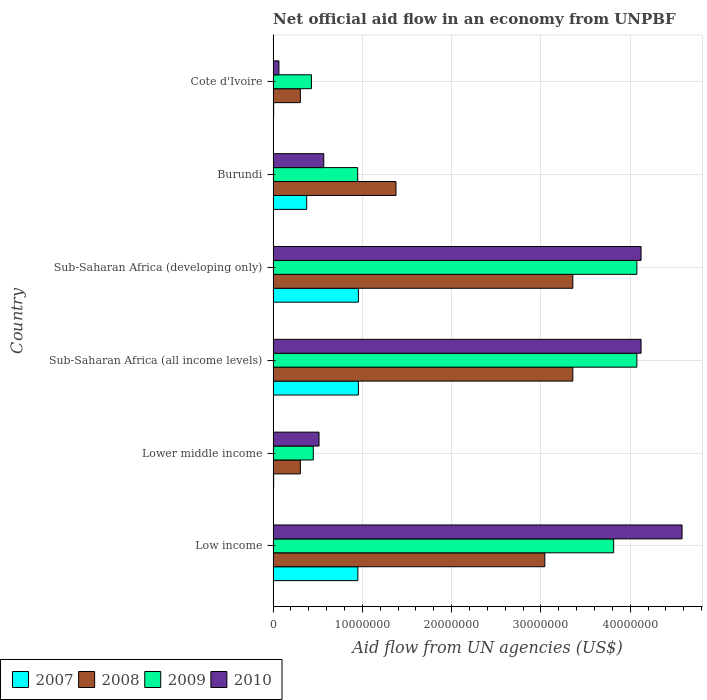How many groups of bars are there?
Keep it short and to the point. 6. Are the number of bars per tick equal to the number of legend labels?
Provide a short and direct response. Yes. Are the number of bars on each tick of the Y-axis equal?
Your answer should be compact. Yes. How many bars are there on the 1st tick from the top?
Your response must be concise. 4. What is the label of the 2nd group of bars from the top?
Your answer should be very brief. Burundi. What is the net official aid flow in 2008 in Sub-Saharan Africa (developing only)?
Give a very brief answer. 3.36e+07. Across all countries, what is the maximum net official aid flow in 2010?
Offer a very short reply. 4.58e+07. Across all countries, what is the minimum net official aid flow in 2008?
Offer a terse response. 3.05e+06. In which country was the net official aid flow in 2009 maximum?
Your answer should be very brief. Sub-Saharan Africa (all income levels). In which country was the net official aid flow in 2007 minimum?
Offer a very short reply. Lower middle income. What is the total net official aid flow in 2010 in the graph?
Offer a terse response. 1.40e+08. What is the difference between the net official aid flow in 2009 in Low income and that in Lower middle income?
Provide a succinct answer. 3.36e+07. What is the difference between the net official aid flow in 2009 in Lower middle income and the net official aid flow in 2007 in Cote d'Ivoire?
Offer a very short reply. 4.44e+06. What is the average net official aid flow in 2008 per country?
Provide a short and direct response. 1.96e+07. What is the difference between the net official aid flow in 2007 and net official aid flow in 2010 in Cote d'Ivoire?
Your answer should be compact. -5.90e+05. In how many countries, is the net official aid flow in 2010 greater than 42000000 US$?
Offer a very short reply. 1. Is the difference between the net official aid flow in 2007 in Burundi and Low income greater than the difference between the net official aid flow in 2010 in Burundi and Low income?
Provide a succinct answer. Yes. What is the difference between the highest and the second highest net official aid flow in 2008?
Your answer should be compact. 0. What is the difference between the highest and the lowest net official aid flow in 2007?
Provide a short and direct response. 9.49e+06. In how many countries, is the net official aid flow in 2008 greater than the average net official aid flow in 2008 taken over all countries?
Provide a succinct answer. 3. What does the 1st bar from the top in Sub-Saharan Africa (developing only) represents?
Offer a terse response. 2010. Is it the case that in every country, the sum of the net official aid flow in 2009 and net official aid flow in 2007 is greater than the net official aid flow in 2010?
Your answer should be compact. No. How many countries are there in the graph?
Offer a very short reply. 6. Are the values on the major ticks of X-axis written in scientific E-notation?
Provide a short and direct response. No. Does the graph contain grids?
Offer a very short reply. Yes. How many legend labels are there?
Offer a terse response. 4. What is the title of the graph?
Your answer should be compact. Net official aid flow in an economy from UNPBF. Does "2009" appear as one of the legend labels in the graph?
Ensure brevity in your answer.  Yes. What is the label or title of the X-axis?
Ensure brevity in your answer.  Aid flow from UN agencies (US$). What is the Aid flow from UN agencies (US$) in 2007 in Low income?
Make the answer very short. 9.49e+06. What is the Aid flow from UN agencies (US$) in 2008 in Low income?
Your answer should be very brief. 3.04e+07. What is the Aid flow from UN agencies (US$) in 2009 in Low income?
Offer a terse response. 3.81e+07. What is the Aid flow from UN agencies (US$) of 2010 in Low income?
Offer a very short reply. 4.58e+07. What is the Aid flow from UN agencies (US$) of 2008 in Lower middle income?
Make the answer very short. 3.05e+06. What is the Aid flow from UN agencies (US$) in 2009 in Lower middle income?
Your answer should be very brief. 4.50e+06. What is the Aid flow from UN agencies (US$) of 2010 in Lower middle income?
Give a very brief answer. 5.14e+06. What is the Aid flow from UN agencies (US$) in 2007 in Sub-Saharan Africa (all income levels)?
Make the answer very short. 9.55e+06. What is the Aid flow from UN agencies (US$) in 2008 in Sub-Saharan Africa (all income levels)?
Provide a short and direct response. 3.36e+07. What is the Aid flow from UN agencies (US$) of 2009 in Sub-Saharan Africa (all income levels)?
Offer a very short reply. 4.07e+07. What is the Aid flow from UN agencies (US$) in 2010 in Sub-Saharan Africa (all income levels)?
Your answer should be very brief. 4.12e+07. What is the Aid flow from UN agencies (US$) of 2007 in Sub-Saharan Africa (developing only)?
Your answer should be compact. 9.55e+06. What is the Aid flow from UN agencies (US$) of 2008 in Sub-Saharan Africa (developing only)?
Offer a very short reply. 3.36e+07. What is the Aid flow from UN agencies (US$) in 2009 in Sub-Saharan Africa (developing only)?
Offer a terse response. 4.07e+07. What is the Aid flow from UN agencies (US$) of 2010 in Sub-Saharan Africa (developing only)?
Your response must be concise. 4.12e+07. What is the Aid flow from UN agencies (US$) in 2007 in Burundi?
Provide a succinct answer. 3.76e+06. What is the Aid flow from UN agencies (US$) of 2008 in Burundi?
Your answer should be compact. 1.38e+07. What is the Aid flow from UN agencies (US$) of 2009 in Burundi?
Your answer should be compact. 9.47e+06. What is the Aid flow from UN agencies (US$) of 2010 in Burundi?
Your answer should be compact. 5.67e+06. What is the Aid flow from UN agencies (US$) in 2008 in Cote d'Ivoire?
Provide a short and direct response. 3.05e+06. What is the Aid flow from UN agencies (US$) in 2009 in Cote d'Ivoire?
Your answer should be compact. 4.29e+06. What is the Aid flow from UN agencies (US$) of 2010 in Cote d'Ivoire?
Provide a short and direct response. 6.50e+05. Across all countries, what is the maximum Aid flow from UN agencies (US$) of 2007?
Provide a succinct answer. 9.55e+06. Across all countries, what is the maximum Aid flow from UN agencies (US$) in 2008?
Ensure brevity in your answer.  3.36e+07. Across all countries, what is the maximum Aid flow from UN agencies (US$) in 2009?
Your answer should be very brief. 4.07e+07. Across all countries, what is the maximum Aid flow from UN agencies (US$) in 2010?
Your response must be concise. 4.58e+07. Across all countries, what is the minimum Aid flow from UN agencies (US$) in 2008?
Offer a terse response. 3.05e+06. Across all countries, what is the minimum Aid flow from UN agencies (US$) in 2009?
Your answer should be very brief. 4.29e+06. Across all countries, what is the minimum Aid flow from UN agencies (US$) of 2010?
Your response must be concise. 6.50e+05. What is the total Aid flow from UN agencies (US$) of 2007 in the graph?
Provide a succinct answer. 3.25e+07. What is the total Aid flow from UN agencies (US$) in 2008 in the graph?
Your answer should be very brief. 1.17e+08. What is the total Aid flow from UN agencies (US$) in 2009 in the graph?
Keep it short and to the point. 1.38e+08. What is the total Aid flow from UN agencies (US$) of 2010 in the graph?
Provide a short and direct response. 1.40e+08. What is the difference between the Aid flow from UN agencies (US$) of 2007 in Low income and that in Lower middle income?
Make the answer very short. 9.43e+06. What is the difference between the Aid flow from UN agencies (US$) in 2008 in Low income and that in Lower middle income?
Make the answer very short. 2.74e+07. What is the difference between the Aid flow from UN agencies (US$) of 2009 in Low income and that in Lower middle income?
Your answer should be very brief. 3.36e+07. What is the difference between the Aid flow from UN agencies (US$) of 2010 in Low income and that in Lower middle income?
Your answer should be compact. 4.07e+07. What is the difference between the Aid flow from UN agencies (US$) of 2007 in Low income and that in Sub-Saharan Africa (all income levels)?
Keep it short and to the point. -6.00e+04. What is the difference between the Aid flow from UN agencies (US$) in 2008 in Low income and that in Sub-Saharan Africa (all income levels)?
Keep it short and to the point. -3.14e+06. What is the difference between the Aid flow from UN agencies (US$) in 2009 in Low income and that in Sub-Saharan Africa (all income levels)?
Keep it short and to the point. -2.60e+06. What is the difference between the Aid flow from UN agencies (US$) of 2010 in Low income and that in Sub-Saharan Africa (all income levels)?
Provide a short and direct response. 4.59e+06. What is the difference between the Aid flow from UN agencies (US$) in 2007 in Low income and that in Sub-Saharan Africa (developing only)?
Provide a short and direct response. -6.00e+04. What is the difference between the Aid flow from UN agencies (US$) in 2008 in Low income and that in Sub-Saharan Africa (developing only)?
Your answer should be very brief. -3.14e+06. What is the difference between the Aid flow from UN agencies (US$) of 2009 in Low income and that in Sub-Saharan Africa (developing only)?
Your response must be concise. -2.60e+06. What is the difference between the Aid flow from UN agencies (US$) in 2010 in Low income and that in Sub-Saharan Africa (developing only)?
Offer a terse response. 4.59e+06. What is the difference between the Aid flow from UN agencies (US$) of 2007 in Low income and that in Burundi?
Your answer should be very brief. 5.73e+06. What is the difference between the Aid flow from UN agencies (US$) in 2008 in Low income and that in Burundi?
Offer a very short reply. 1.67e+07. What is the difference between the Aid flow from UN agencies (US$) in 2009 in Low income and that in Burundi?
Your answer should be compact. 2.87e+07. What is the difference between the Aid flow from UN agencies (US$) in 2010 in Low income and that in Burundi?
Make the answer very short. 4.01e+07. What is the difference between the Aid flow from UN agencies (US$) of 2007 in Low income and that in Cote d'Ivoire?
Make the answer very short. 9.43e+06. What is the difference between the Aid flow from UN agencies (US$) in 2008 in Low income and that in Cote d'Ivoire?
Make the answer very short. 2.74e+07. What is the difference between the Aid flow from UN agencies (US$) in 2009 in Low income and that in Cote d'Ivoire?
Offer a very short reply. 3.38e+07. What is the difference between the Aid flow from UN agencies (US$) of 2010 in Low income and that in Cote d'Ivoire?
Your answer should be very brief. 4.52e+07. What is the difference between the Aid flow from UN agencies (US$) in 2007 in Lower middle income and that in Sub-Saharan Africa (all income levels)?
Offer a terse response. -9.49e+06. What is the difference between the Aid flow from UN agencies (US$) of 2008 in Lower middle income and that in Sub-Saharan Africa (all income levels)?
Your answer should be compact. -3.05e+07. What is the difference between the Aid flow from UN agencies (US$) of 2009 in Lower middle income and that in Sub-Saharan Africa (all income levels)?
Your response must be concise. -3.62e+07. What is the difference between the Aid flow from UN agencies (US$) in 2010 in Lower middle income and that in Sub-Saharan Africa (all income levels)?
Offer a very short reply. -3.61e+07. What is the difference between the Aid flow from UN agencies (US$) in 2007 in Lower middle income and that in Sub-Saharan Africa (developing only)?
Provide a succinct answer. -9.49e+06. What is the difference between the Aid flow from UN agencies (US$) in 2008 in Lower middle income and that in Sub-Saharan Africa (developing only)?
Your answer should be very brief. -3.05e+07. What is the difference between the Aid flow from UN agencies (US$) in 2009 in Lower middle income and that in Sub-Saharan Africa (developing only)?
Ensure brevity in your answer.  -3.62e+07. What is the difference between the Aid flow from UN agencies (US$) of 2010 in Lower middle income and that in Sub-Saharan Africa (developing only)?
Provide a short and direct response. -3.61e+07. What is the difference between the Aid flow from UN agencies (US$) in 2007 in Lower middle income and that in Burundi?
Your response must be concise. -3.70e+06. What is the difference between the Aid flow from UN agencies (US$) in 2008 in Lower middle income and that in Burundi?
Make the answer very short. -1.07e+07. What is the difference between the Aid flow from UN agencies (US$) in 2009 in Lower middle income and that in Burundi?
Ensure brevity in your answer.  -4.97e+06. What is the difference between the Aid flow from UN agencies (US$) in 2010 in Lower middle income and that in Burundi?
Your answer should be very brief. -5.30e+05. What is the difference between the Aid flow from UN agencies (US$) in 2007 in Lower middle income and that in Cote d'Ivoire?
Offer a very short reply. 0. What is the difference between the Aid flow from UN agencies (US$) in 2009 in Lower middle income and that in Cote d'Ivoire?
Provide a short and direct response. 2.10e+05. What is the difference between the Aid flow from UN agencies (US$) in 2010 in Lower middle income and that in Cote d'Ivoire?
Your response must be concise. 4.49e+06. What is the difference between the Aid flow from UN agencies (US$) of 2007 in Sub-Saharan Africa (all income levels) and that in Sub-Saharan Africa (developing only)?
Keep it short and to the point. 0. What is the difference between the Aid flow from UN agencies (US$) in 2010 in Sub-Saharan Africa (all income levels) and that in Sub-Saharan Africa (developing only)?
Provide a succinct answer. 0. What is the difference between the Aid flow from UN agencies (US$) of 2007 in Sub-Saharan Africa (all income levels) and that in Burundi?
Provide a short and direct response. 5.79e+06. What is the difference between the Aid flow from UN agencies (US$) of 2008 in Sub-Saharan Africa (all income levels) and that in Burundi?
Make the answer very short. 1.98e+07. What is the difference between the Aid flow from UN agencies (US$) in 2009 in Sub-Saharan Africa (all income levels) and that in Burundi?
Your answer should be compact. 3.13e+07. What is the difference between the Aid flow from UN agencies (US$) of 2010 in Sub-Saharan Africa (all income levels) and that in Burundi?
Offer a very short reply. 3.55e+07. What is the difference between the Aid flow from UN agencies (US$) in 2007 in Sub-Saharan Africa (all income levels) and that in Cote d'Ivoire?
Provide a succinct answer. 9.49e+06. What is the difference between the Aid flow from UN agencies (US$) in 2008 in Sub-Saharan Africa (all income levels) and that in Cote d'Ivoire?
Keep it short and to the point. 3.05e+07. What is the difference between the Aid flow from UN agencies (US$) of 2009 in Sub-Saharan Africa (all income levels) and that in Cote d'Ivoire?
Your answer should be very brief. 3.64e+07. What is the difference between the Aid flow from UN agencies (US$) of 2010 in Sub-Saharan Africa (all income levels) and that in Cote d'Ivoire?
Your answer should be compact. 4.06e+07. What is the difference between the Aid flow from UN agencies (US$) in 2007 in Sub-Saharan Africa (developing only) and that in Burundi?
Ensure brevity in your answer.  5.79e+06. What is the difference between the Aid flow from UN agencies (US$) in 2008 in Sub-Saharan Africa (developing only) and that in Burundi?
Your answer should be compact. 1.98e+07. What is the difference between the Aid flow from UN agencies (US$) in 2009 in Sub-Saharan Africa (developing only) and that in Burundi?
Give a very brief answer. 3.13e+07. What is the difference between the Aid flow from UN agencies (US$) in 2010 in Sub-Saharan Africa (developing only) and that in Burundi?
Make the answer very short. 3.55e+07. What is the difference between the Aid flow from UN agencies (US$) of 2007 in Sub-Saharan Africa (developing only) and that in Cote d'Ivoire?
Provide a succinct answer. 9.49e+06. What is the difference between the Aid flow from UN agencies (US$) of 2008 in Sub-Saharan Africa (developing only) and that in Cote d'Ivoire?
Offer a terse response. 3.05e+07. What is the difference between the Aid flow from UN agencies (US$) of 2009 in Sub-Saharan Africa (developing only) and that in Cote d'Ivoire?
Your answer should be compact. 3.64e+07. What is the difference between the Aid flow from UN agencies (US$) in 2010 in Sub-Saharan Africa (developing only) and that in Cote d'Ivoire?
Offer a terse response. 4.06e+07. What is the difference between the Aid flow from UN agencies (US$) of 2007 in Burundi and that in Cote d'Ivoire?
Your answer should be very brief. 3.70e+06. What is the difference between the Aid flow from UN agencies (US$) in 2008 in Burundi and that in Cote d'Ivoire?
Ensure brevity in your answer.  1.07e+07. What is the difference between the Aid flow from UN agencies (US$) in 2009 in Burundi and that in Cote d'Ivoire?
Ensure brevity in your answer.  5.18e+06. What is the difference between the Aid flow from UN agencies (US$) in 2010 in Burundi and that in Cote d'Ivoire?
Give a very brief answer. 5.02e+06. What is the difference between the Aid flow from UN agencies (US$) of 2007 in Low income and the Aid flow from UN agencies (US$) of 2008 in Lower middle income?
Provide a succinct answer. 6.44e+06. What is the difference between the Aid flow from UN agencies (US$) of 2007 in Low income and the Aid flow from UN agencies (US$) of 2009 in Lower middle income?
Your answer should be compact. 4.99e+06. What is the difference between the Aid flow from UN agencies (US$) of 2007 in Low income and the Aid flow from UN agencies (US$) of 2010 in Lower middle income?
Make the answer very short. 4.35e+06. What is the difference between the Aid flow from UN agencies (US$) of 2008 in Low income and the Aid flow from UN agencies (US$) of 2009 in Lower middle income?
Offer a terse response. 2.59e+07. What is the difference between the Aid flow from UN agencies (US$) of 2008 in Low income and the Aid flow from UN agencies (US$) of 2010 in Lower middle income?
Ensure brevity in your answer.  2.53e+07. What is the difference between the Aid flow from UN agencies (US$) of 2009 in Low income and the Aid flow from UN agencies (US$) of 2010 in Lower middle income?
Your answer should be very brief. 3.30e+07. What is the difference between the Aid flow from UN agencies (US$) of 2007 in Low income and the Aid flow from UN agencies (US$) of 2008 in Sub-Saharan Africa (all income levels)?
Provide a short and direct response. -2.41e+07. What is the difference between the Aid flow from UN agencies (US$) of 2007 in Low income and the Aid flow from UN agencies (US$) of 2009 in Sub-Saharan Africa (all income levels)?
Keep it short and to the point. -3.12e+07. What is the difference between the Aid flow from UN agencies (US$) of 2007 in Low income and the Aid flow from UN agencies (US$) of 2010 in Sub-Saharan Africa (all income levels)?
Give a very brief answer. -3.17e+07. What is the difference between the Aid flow from UN agencies (US$) in 2008 in Low income and the Aid flow from UN agencies (US$) in 2009 in Sub-Saharan Africa (all income levels)?
Ensure brevity in your answer.  -1.03e+07. What is the difference between the Aid flow from UN agencies (US$) of 2008 in Low income and the Aid flow from UN agencies (US$) of 2010 in Sub-Saharan Africa (all income levels)?
Provide a succinct answer. -1.08e+07. What is the difference between the Aid flow from UN agencies (US$) in 2009 in Low income and the Aid flow from UN agencies (US$) in 2010 in Sub-Saharan Africa (all income levels)?
Your response must be concise. -3.07e+06. What is the difference between the Aid flow from UN agencies (US$) in 2007 in Low income and the Aid flow from UN agencies (US$) in 2008 in Sub-Saharan Africa (developing only)?
Your answer should be very brief. -2.41e+07. What is the difference between the Aid flow from UN agencies (US$) of 2007 in Low income and the Aid flow from UN agencies (US$) of 2009 in Sub-Saharan Africa (developing only)?
Ensure brevity in your answer.  -3.12e+07. What is the difference between the Aid flow from UN agencies (US$) in 2007 in Low income and the Aid flow from UN agencies (US$) in 2010 in Sub-Saharan Africa (developing only)?
Your answer should be very brief. -3.17e+07. What is the difference between the Aid flow from UN agencies (US$) in 2008 in Low income and the Aid flow from UN agencies (US$) in 2009 in Sub-Saharan Africa (developing only)?
Provide a short and direct response. -1.03e+07. What is the difference between the Aid flow from UN agencies (US$) in 2008 in Low income and the Aid flow from UN agencies (US$) in 2010 in Sub-Saharan Africa (developing only)?
Keep it short and to the point. -1.08e+07. What is the difference between the Aid flow from UN agencies (US$) of 2009 in Low income and the Aid flow from UN agencies (US$) of 2010 in Sub-Saharan Africa (developing only)?
Offer a terse response. -3.07e+06. What is the difference between the Aid flow from UN agencies (US$) in 2007 in Low income and the Aid flow from UN agencies (US$) in 2008 in Burundi?
Your answer should be compact. -4.27e+06. What is the difference between the Aid flow from UN agencies (US$) in 2007 in Low income and the Aid flow from UN agencies (US$) in 2009 in Burundi?
Provide a succinct answer. 2.00e+04. What is the difference between the Aid flow from UN agencies (US$) of 2007 in Low income and the Aid flow from UN agencies (US$) of 2010 in Burundi?
Provide a short and direct response. 3.82e+06. What is the difference between the Aid flow from UN agencies (US$) in 2008 in Low income and the Aid flow from UN agencies (US$) in 2009 in Burundi?
Ensure brevity in your answer.  2.10e+07. What is the difference between the Aid flow from UN agencies (US$) in 2008 in Low income and the Aid flow from UN agencies (US$) in 2010 in Burundi?
Your response must be concise. 2.48e+07. What is the difference between the Aid flow from UN agencies (US$) in 2009 in Low income and the Aid flow from UN agencies (US$) in 2010 in Burundi?
Your response must be concise. 3.25e+07. What is the difference between the Aid flow from UN agencies (US$) of 2007 in Low income and the Aid flow from UN agencies (US$) of 2008 in Cote d'Ivoire?
Ensure brevity in your answer.  6.44e+06. What is the difference between the Aid flow from UN agencies (US$) of 2007 in Low income and the Aid flow from UN agencies (US$) of 2009 in Cote d'Ivoire?
Your response must be concise. 5.20e+06. What is the difference between the Aid flow from UN agencies (US$) of 2007 in Low income and the Aid flow from UN agencies (US$) of 2010 in Cote d'Ivoire?
Give a very brief answer. 8.84e+06. What is the difference between the Aid flow from UN agencies (US$) of 2008 in Low income and the Aid flow from UN agencies (US$) of 2009 in Cote d'Ivoire?
Offer a very short reply. 2.61e+07. What is the difference between the Aid flow from UN agencies (US$) in 2008 in Low income and the Aid flow from UN agencies (US$) in 2010 in Cote d'Ivoire?
Make the answer very short. 2.98e+07. What is the difference between the Aid flow from UN agencies (US$) of 2009 in Low income and the Aid flow from UN agencies (US$) of 2010 in Cote d'Ivoire?
Keep it short and to the point. 3.75e+07. What is the difference between the Aid flow from UN agencies (US$) of 2007 in Lower middle income and the Aid flow from UN agencies (US$) of 2008 in Sub-Saharan Africa (all income levels)?
Provide a short and direct response. -3.35e+07. What is the difference between the Aid flow from UN agencies (US$) in 2007 in Lower middle income and the Aid flow from UN agencies (US$) in 2009 in Sub-Saharan Africa (all income levels)?
Offer a very short reply. -4.07e+07. What is the difference between the Aid flow from UN agencies (US$) in 2007 in Lower middle income and the Aid flow from UN agencies (US$) in 2010 in Sub-Saharan Africa (all income levels)?
Make the answer very short. -4.12e+07. What is the difference between the Aid flow from UN agencies (US$) in 2008 in Lower middle income and the Aid flow from UN agencies (US$) in 2009 in Sub-Saharan Africa (all income levels)?
Ensure brevity in your answer.  -3.77e+07. What is the difference between the Aid flow from UN agencies (US$) in 2008 in Lower middle income and the Aid flow from UN agencies (US$) in 2010 in Sub-Saharan Africa (all income levels)?
Offer a very short reply. -3.82e+07. What is the difference between the Aid flow from UN agencies (US$) in 2009 in Lower middle income and the Aid flow from UN agencies (US$) in 2010 in Sub-Saharan Africa (all income levels)?
Keep it short and to the point. -3.67e+07. What is the difference between the Aid flow from UN agencies (US$) of 2007 in Lower middle income and the Aid flow from UN agencies (US$) of 2008 in Sub-Saharan Africa (developing only)?
Your answer should be compact. -3.35e+07. What is the difference between the Aid flow from UN agencies (US$) in 2007 in Lower middle income and the Aid flow from UN agencies (US$) in 2009 in Sub-Saharan Africa (developing only)?
Offer a very short reply. -4.07e+07. What is the difference between the Aid flow from UN agencies (US$) of 2007 in Lower middle income and the Aid flow from UN agencies (US$) of 2010 in Sub-Saharan Africa (developing only)?
Your answer should be compact. -4.12e+07. What is the difference between the Aid flow from UN agencies (US$) in 2008 in Lower middle income and the Aid flow from UN agencies (US$) in 2009 in Sub-Saharan Africa (developing only)?
Offer a very short reply. -3.77e+07. What is the difference between the Aid flow from UN agencies (US$) in 2008 in Lower middle income and the Aid flow from UN agencies (US$) in 2010 in Sub-Saharan Africa (developing only)?
Ensure brevity in your answer.  -3.82e+07. What is the difference between the Aid flow from UN agencies (US$) in 2009 in Lower middle income and the Aid flow from UN agencies (US$) in 2010 in Sub-Saharan Africa (developing only)?
Your response must be concise. -3.67e+07. What is the difference between the Aid flow from UN agencies (US$) of 2007 in Lower middle income and the Aid flow from UN agencies (US$) of 2008 in Burundi?
Keep it short and to the point. -1.37e+07. What is the difference between the Aid flow from UN agencies (US$) in 2007 in Lower middle income and the Aid flow from UN agencies (US$) in 2009 in Burundi?
Your answer should be compact. -9.41e+06. What is the difference between the Aid flow from UN agencies (US$) of 2007 in Lower middle income and the Aid flow from UN agencies (US$) of 2010 in Burundi?
Ensure brevity in your answer.  -5.61e+06. What is the difference between the Aid flow from UN agencies (US$) in 2008 in Lower middle income and the Aid flow from UN agencies (US$) in 2009 in Burundi?
Offer a very short reply. -6.42e+06. What is the difference between the Aid flow from UN agencies (US$) in 2008 in Lower middle income and the Aid flow from UN agencies (US$) in 2010 in Burundi?
Your response must be concise. -2.62e+06. What is the difference between the Aid flow from UN agencies (US$) of 2009 in Lower middle income and the Aid flow from UN agencies (US$) of 2010 in Burundi?
Provide a short and direct response. -1.17e+06. What is the difference between the Aid flow from UN agencies (US$) in 2007 in Lower middle income and the Aid flow from UN agencies (US$) in 2008 in Cote d'Ivoire?
Provide a succinct answer. -2.99e+06. What is the difference between the Aid flow from UN agencies (US$) of 2007 in Lower middle income and the Aid flow from UN agencies (US$) of 2009 in Cote d'Ivoire?
Provide a succinct answer. -4.23e+06. What is the difference between the Aid flow from UN agencies (US$) of 2007 in Lower middle income and the Aid flow from UN agencies (US$) of 2010 in Cote d'Ivoire?
Keep it short and to the point. -5.90e+05. What is the difference between the Aid flow from UN agencies (US$) in 2008 in Lower middle income and the Aid flow from UN agencies (US$) in 2009 in Cote d'Ivoire?
Keep it short and to the point. -1.24e+06. What is the difference between the Aid flow from UN agencies (US$) in 2008 in Lower middle income and the Aid flow from UN agencies (US$) in 2010 in Cote d'Ivoire?
Give a very brief answer. 2.40e+06. What is the difference between the Aid flow from UN agencies (US$) of 2009 in Lower middle income and the Aid flow from UN agencies (US$) of 2010 in Cote d'Ivoire?
Make the answer very short. 3.85e+06. What is the difference between the Aid flow from UN agencies (US$) in 2007 in Sub-Saharan Africa (all income levels) and the Aid flow from UN agencies (US$) in 2008 in Sub-Saharan Africa (developing only)?
Your response must be concise. -2.40e+07. What is the difference between the Aid flow from UN agencies (US$) of 2007 in Sub-Saharan Africa (all income levels) and the Aid flow from UN agencies (US$) of 2009 in Sub-Saharan Africa (developing only)?
Make the answer very short. -3.12e+07. What is the difference between the Aid flow from UN agencies (US$) of 2007 in Sub-Saharan Africa (all income levels) and the Aid flow from UN agencies (US$) of 2010 in Sub-Saharan Africa (developing only)?
Your answer should be very brief. -3.17e+07. What is the difference between the Aid flow from UN agencies (US$) in 2008 in Sub-Saharan Africa (all income levels) and the Aid flow from UN agencies (US$) in 2009 in Sub-Saharan Africa (developing only)?
Ensure brevity in your answer.  -7.17e+06. What is the difference between the Aid flow from UN agencies (US$) of 2008 in Sub-Saharan Africa (all income levels) and the Aid flow from UN agencies (US$) of 2010 in Sub-Saharan Africa (developing only)?
Ensure brevity in your answer.  -7.64e+06. What is the difference between the Aid flow from UN agencies (US$) in 2009 in Sub-Saharan Africa (all income levels) and the Aid flow from UN agencies (US$) in 2010 in Sub-Saharan Africa (developing only)?
Make the answer very short. -4.70e+05. What is the difference between the Aid flow from UN agencies (US$) of 2007 in Sub-Saharan Africa (all income levels) and the Aid flow from UN agencies (US$) of 2008 in Burundi?
Your answer should be very brief. -4.21e+06. What is the difference between the Aid flow from UN agencies (US$) in 2007 in Sub-Saharan Africa (all income levels) and the Aid flow from UN agencies (US$) in 2009 in Burundi?
Your answer should be very brief. 8.00e+04. What is the difference between the Aid flow from UN agencies (US$) of 2007 in Sub-Saharan Africa (all income levels) and the Aid flow from UN agencies (US$) of 2010 in Burundi?
Your response must be concise. 3.88e+06. What is the difference between the Aid flow from UN agencies (US$) in 2008 in Sub-Saharan Africa (all income levels) and the Aid flow from UN agencies (US$) in 2009 in Burundi?
Ensure brevity in your answer.  2.41e+07. What is the difference between the Aid flow from UN agencies (US$) in 2008 in Sub-Saharan Africa (all income levels) and the Aid flow from UN agencies (US$) in 2010 in Burundi?
Give a very brief answer. 2.79e+07. What is the difference between the Aid flow from UN agencies (US$) of 2009 in Sub-Saharan Africa (all income levels) and the Aid flow from UN agencies (US$) of 2010 in Burundi?
Offer a very short reply. 3.51e+07. What is the difference between the Aid flow from UN agencies (US$) of 2007 in Sub-Saharan Africa (all income levels) and the Aid flow from UN agencies (US$) of 2008 in Cote d'Ivoire?
Make the answer very short. 6.50e+06. What is the difference between the Aid flow from UN agencies (US$) in 2007 in Sub-Saharan Africa (all income levels) and the Aid flow from UN agencies (US$) in 2009 in Cote d'Ivoire?
Offer a terse response. 5.26e+06. What is the difference between the Aid flow from UN agencies (US$) in 2007 in Sub-Saharan Africa (all income levels) and the Aid flow from UN agencies (US$) in 2010 in Cote d'Ivoire?
Your response must be concise. 8.90e+06. What is the difference between the Aid flow from UN agencies (US$) in 2008 in Sub-Saharan Africa (all income levels) and the Aid flow from UN agencies (US$) in 2009 in Cote d'Ivoire?
Give a very brief answer. 2.93e+07. What is the difference between the Aid flow from UN agencies (US$) in 2008 in Sub-Saharan Africa (all income levels) and the Aid flow from UN agencies (US$) in 2010 in Cote d'Ivoire?
Your response must be concise. 3.29e+07. What is the difference between the Aid flow from UN agencies (US$) of 2009 in Sub-Saharan Africa (all income levels) and the Aid flow from UN agencies (US$) of 2010 in Cote d'Ivoire?
Offer a very short reply. 4.01e+07. What is the difference between the Aid flow from UN agencies (US$) in 2007 in Sub-Saharan Africa (developing only) and the Aid flow from UN agencies (US$) in 2008 in Burundi?
Offer a terse response. -4.21e+06. What is the difference between the Aid flow from UN agencies (US$) of 2007 in Sub-Saharan Africa (developing only) and the Aid flow from UN agencies (US$) of 2010 in Burundi?
Ensure brevity in your answer.  3.88e+06. What is the difference between the Aid flow from UN agencies (US$) in 2008 in Sub-Saharan Africa (developing only) and the Aid flow from UN agencies (US$) in 2009 in Burundi?
Offer a very short reply. 2.41e+07. What is the difference between the Aid flow from UN agencies (US$) of 2008 in Sub-Saharan Africa (developing only) and the Aid flow from UN agencies (US$) of 2010 in Burundi?
Make the answer very short. 2.79e+07. What is the difference between the Aid flow from UN agencies (US$) of 2009 in Sub-Saharan Africa (developing only) and the Aid flow from UN agencies (US$) of 2010 in Burundi?
Your answer should be very brief. 3.51e+07. What is the difference between the Aid flow from UN agencies (US$) in 2007 in Sub-Saharan Africa (developing only) and the Aid flow from UN agencies (US$) in 2008 in Cote d'Ivoire?
Make the answer very short. 6.50e+06. What is the difference between the Aid flow from UN agencies (US$) in 2007 in Sub-Saharan Africa (developing only) and the Aid flow from UN agencies (US$) in 2009 in Cote d'Ivoire?
Offer a very short reply. 5.26e+06. What is the difference between the Aid flow from UN agencies (US$) in 2007 in Sub-Saharan Africa (developing only) and the Aid flow from UN agencies (US$) in 2010 in Cote d'Ivoire?
Ensure brevity in your answer.  8.90e+06. What is the difference between the Aid flow from UN agencies (US$) in 2008 in Sub-Saharan Africa (developing only) and the Aid flow from UN agencies (US$) in 2009 in Cote d'Ivoire?
Give a very brief answer. 2.93e+07. What is the difference between the Aid flow from UN agencies (US$) in 2008 in Sub-Saharan Africa (developing only) and the Aid flow from UN agencies (US$) in 2010 in Cote d'Ivoire?
Make the answer very short. 3.29e+07. What is the difference between the Aid flow from UN agencies (US$) in 2009 in Sub-Saharan Africa (developing only) and the Aid flow from UN agencies (US$) in 2010 in Cote d'Ivoire?
Offer a terse response. 4.01e+07. What is the difference between the Aid flow from UN agencies (US$) in 2007 in Burundi and the Aid flow from UN agencies (US$) in 2008 in Cote d'Ivoire?
Ensure brevity in your answer.  7.10e+05. What is the difference between the Aid flow from UN agencies (US$) in 2007 in Burundi and the Aid flow from UN agencies (US$) in 2009 in Cote d'Ivoire?
Offer a terse response. -5.30e+05. What is the difference between the Aid flow from UN agencies (US$) of 2007 in Burundi and the Aid flow from UN agencies (US$) of 2010 in Cote d'Ivoire?
Offer a terse response. 3.11e+06. What is the difference between the Aid flow from UN agencies (US$) of 2008 in Burundi and the Aid flow from UN agencies (US$) of 2009 in Cote d'Ivoire?
Provide a short and direct response. 9.47e+06. What is the difference between the Aid flow from UN agencies (US$) in 2008 in Burundi and the Aid flow from UN agencies (US$) in 2010 in Cote d'Ivoire?
Your answer should be compact. 1.31e+07. What is the difference between the Aid flow from UN agencies (US$) in 2009 in Burundi and the Aid flow from UN agencies (US$) in 2010 in Cote d'Ivoire?
Make the answer very short. 8.82e+06. What is the average Aid flow from UN agencies (US$) in 2007 per country?
Give a very brief answer. 5.41e+06. What is the average Aid flow from UN agencies (US$) in 2008 per country?
Ensure brevity in your answer.  1.96e+07. What is the average Aid flow from UN agencies (US$) of 2009 per country?
Provide a short and direct response. 2.30e+07. What is the average Aid flow from UN agencies (US$) in 2010 per country?
Your answer should be very brief. 2.33e+07. What is the difference between the Aid flow from UN agencies (US$) in 2007 and Aid flow from UN agencies (US$) in 2008 in Low income?
Ensure brevity in your answer.  -2.09e+07. What is the difference between the Aid flow from UN agencies (US$) of 2007 and Aid flow from UN agencies (US$) of 2009 in Low income?
Keep it short and to the point. -2.86e+07. What is the difference between the Aid flow from UN agencies (US$) of 2007 and Aid flow from UN agencies (US$) of 2010 in Low income?
Your response must be concise. -3.63e+07. What is the difference between the Aid flow from UN agencies (US$) in 2008 and Aid flow from UN agencies (US$) in 2009 in Low income?
Provide a short and direct response. -7.71e+06. What is the difference between the Aid flow from UN agencies (US$) in 2008 and Aid flow from UN agencies (US$) in 2010 in Low income?
Offer a very short reply. -1.54e+07. What is the difference between the Aid flow from UN agencies (US$) of 2009 and Aid flow from UN agencies (US$) of 2010 in Low income?
Your answer should be compact. -7.66e+06. What is the difference between the Aid flow from UN agencies (US$) of 2007 and Aid flow from UN agencies (US$) of 2008 in Lower middle income?
Provide a succinct answer. -2.99e+06. What is the difference between the Aid flow from UN agencies (US$) in 2007 and Aid flow from UN agencies (US$) in 2009 in Lower middle income?
Your response must be concise. -4.44e+06. What is the difference between the Aid flow from UN agencies (US$) in 2007 and Aid flow from UN agencies (US$) in 2010 in Lower middle income?
Ensure brevity in your answer.  -5.08e+06. What is the difference between the Aid flow from UN agencies (US$) in 2008 and Aid flow from UN agencies (US$) in 2009 in Lower middle income?
Provide a succinct answer. -1.45e+06. What is the difference between the Aid flow from UN agencies (US$) in 2008 and Aid flow from UN agencies (US$) in 2010 in Lower middle income?
Your answer should be very brief. -2.09e+06. What is the difference between the Aid flow from UN agencies (US$) in 2009 and Aid flow from UN agencies (US$) in 2010 in Lower middle income?
Provide a short and direct response. -6.40e+05. What is the difference between the Aid flow from UN agencies (US$) of 2007 and Aid flow from UN agencies (US$) of 2008 in Sub-Saharan Africa (all income levels)?
Ensure brevity in your answer.  -2.40e+07. What is the difference between the Aid flow from UN agencies (US$) in 2007 and Aid flow from UN agencies (US$) in 2009 in Sub-Saharan Africa (all income levels)?
Make the answer very short. -3.12e+07. What is the difference between the Aid flow from UN agencies (US$) of 2007 and Aid flow from UN agencies (US$) of 2010 in Sub-Saharan Africa (all income levels)?
Keep it short and to the point. -3.17e+07. What is the difference between the Aid flow from UN agencies (US$) of 2008 and Aid flow from UN agencies (US$) of 2009 in Sub-Saharan Africa (all income levels)?
Offer a very short reply. -7.17e+06. What is the difference between the Aid flow from UN agencies (US$) in 2008 and Aid flow from UN agencies (US$) in 2010 in Sub-Saharan Africa (all income levels)?
Ensure brevity in your answer.  -7.64e+06. What is the difference between the Aid flow from UN agencies (US$) in 2009 and Aid flow from UN agencies (US$) in 2010 in Sub-Saharan Africa (all income levels)?
Your response must be concise. -4.70e+05. What is the difference between the Aid flow from UN agencies (US$) in 2007 and Aid flow from UN agencies (US$) in 2008 in Sub-Saharan Africa (developing only)?
Provide a succinct answer. -2.40e+07. What is the difference between the Aid flow from UN agencies (US$) in 2007 and Aid flow from UN agencies (US$) in 2009 in Sub-Saharan Africa (developing only)?
Your answer should be very brief. -3.12e+07. What is the difference between the Aid flow from UN agencies (US$) in 2007 and Aid flow from UN agencies (US$) in 2010 in Sub-Saharan Africa (developing only)?
Your response must be concise. -3.17e+07. What is the difference between the Aid flow from UN agencies (US$) of 2008 and Aid flow from UN agencies (US$) of 2009 in Sub-Saharan Africa (developing only)?
Your response must be concise. -7.17e+06. What is the difference between the Aid flow from UN agencies (US$) in 2008 and Aid flow from UN agencies (US$) in 2010 in Sub-Saharan Africa (developing only)?
Give a very brief answer. -7.64e+06. What is the difference between the Aid flow from UN agencies (US$) in 2009 and Aid flow from UN agencies (US$) in 2010 in Sub-Saharan Africa (developing only)?
Offer a very short reply. -4.70e+05. What is the difference between the Aid flow from UN agencies (US$) in 2007 and Aid flow from UN agencies (US$) in 2008 in Burundi?
Ensure brevity in your answer.  -1.00e+07. What is the difference between the Aid flow from UN agencies (US$) in 2007 and Aid flow from UN agencies (US$) in 2009 in Burundi?
Provide a succinct answer. -5.71e+06. What is the difference between the Aid flow from UN agencies (US$) in 2007 and Aid flow from UN agencies (US$) in 2010 in Burundi?
Offer a terse response. -1.91e+06. What is the difference between the Aid flow from UN agencies (US$) in 2008 and Aid flow from UN agencies (US$) in 2009 in Burundi?
Provide a succinct answer. 4.29e+06. What is the difference between the Aid flow from UN agencies (US$) of 2008 and Aid flow from UN agencies (US$) of 2010 in Burundi?
Offer a very short reply. 8.09e+06. What is the difference between the Aid flow from UN agencies (US$) in 2009 and Aid flow from UN agencies (US$) in 2010 in Burundi?
Ensure brevity in your answer.  3.80e+06. What is the difference between the Aid flow from UN agencies (US$) in 2007 and Aid flow from UN agencies (US$) in 2008 in Cote d'Ivoire?
Make the answer very short. -2.99e+06. What is the difference between the Aid flow from UN agencies (US$) in 2007 and Aid flow from UN agencies (US$) in 2009 in Cote d'Ivoire?
Offer a very short reply. -4.23e+06. What is the difference between the Aid flow from UN agencies (US$) in 2007 and Aid flow from UN agencies (US$) in 2010 in Cote d'Ivoire?
Your response must be concise. -5.90e+05. What is the difference between the Aid flow from UN agencies (US$) in 2008 and Aid flow from UN agencies (US$) in 2009 in Cote d'Ivoire?
Provide a short and direct response. -1.24e+06. What is the difference between the Aid flow from UN agencies (US$) in 2008 and Aid flow from UN agencies (US$) in 2010 in Cote d'Ivoire?
Provide a succinct answer. 2.40e+06. What is the difference between the Aid flow from UN agencies (US$) of 2009 and Aid flow from UN agencies (US$) of 2010 in Cote d'Ivoire?
Offer a very short reply. 3.64e+06. What is the ratio of the Aid flow from UN agencies (US$) in 2007 in Low income to that in Lower middle income?
Provide a succinct answer. 158.17. What is the ratio of the Aid flow from UN agencies (US$) in 2008 in Low income to that in Lower middle income?
Offer a terse response. 9.98. What is the ratio of the Aid flow from UN agencies (US$) of 2009 in Low income to that in Lower middle income?
Give a very brief answer. 8.48. What is the ratio of the Aid flow from UN agencies (US$) in 2010 in Low income to that in Lower middle income?
Offer a terse response. 8.91. What is the ratio of the Aid flow from UN agencies (US$) in 2007 in Low income to that in Sub-Saharan Africa (all income levels)?
Make the answer very short. 0.99. What is the ratio of the Aid flow from UN agencies (US$) in 2008 in Low income to that in Sub-Saharan Africa (all income levels)?
Ensure brevity in your answer.  0.91. What is the ratio of the Aid flow from UN agencies (US$) of 2009 in Low income to that in Sub-Saharan Africa (all income levels)?
Offer a terse response. 0.94. What is the ratio of the Aid flow from UN agencies (US$) in 2010 in Low income to that in Sub-Saharan Africa (all income levels)?
Ensure brevity in your answer.  1.11. What is the ratio of the Aid flow from UN agencies (US$) of 2008 in Low income to that in Sub-Saharan Africa (developing only)?
Offer a terse response. 0.91. What is the ratio of the Aid flow from UN agencies (US$) of 2009 in Low income to that in Sub-Saharan Africa (developing only)?
Offer a terse response. 0.94. What is the ratio of the Aid flow from UN agencies (US$) of 2010 in Low income to that in Sub-Saharan Africa (developing only)?
Your answer should be very brief. 1.11. What is the ratio of the Aid flow from UN agencies (US$) in 2007 in Low income to that in Burundi?
Your answer should be compact. 2.52. What is the ratio of the Aid flow from UN agencies (US$) of 2008 in Low income to that in Burundi?
Your response must be concise. 2.21. What is the ratio of the Aid flow from UN agencies (US$) in 2009 in Low income to that in Burundi?
Offer a very short reply. 4.03. What is the ratio of the Aid flow from UN agencies (US$) of 2010 in Low income to that in Burundi?
Provide a short and direct response. 8.08. What is the ratio of the Aid flow from UN agencies (US$) in 2007 in Low income to that in Cote d'Ivoire?
Make the answer very short. 158.17. What is the ratio of the Aid flow from UN agencies (US$) in 2008 in Low income to that in Cote d'Ivoire?
Your response must be concise. 9.98. What is the ratio of the Aid flow from UN agencies (US$) of 2009 in Low income to that in Cote d'Ivoire?
Ensure brevity in your answer.  8.89. What is the ratio of the Aid flow from UN agencies (US$) in 2010 in Low income to that in Cote d'Ivoire?
Your answer should be very brief. 70.46. What is the ratio of the Aid flow from UN agencies (US$) of 2007 in Lower middle income to that in Sub-Saharan Africa (all income levels)?
Your response must be concise. 0.01. What is the ratio of the Aid flow from UN agencies (US$) of 2008 in Lower middle income to that in Sub-Saharan Africa (all income levels)?
Provide a succinct answer. 0.09. What is the ratio of the Aid flow from UN agencies (US$) of 2009 in Lower middle income to that in Sub-Saharan Africa (all income levels)?
Provide a short and direct response. 0.11. What is the ratio of the Aid flow from UN agencies (US$) of 2010 in Lower middle income to that in Sub-Saharan Africa (all income levels)?
Provide a short and direct response. 0.12. What is the ratio of the Aid flow from UN agencies (US$) in 2007 in Lower middle income to that in Sub-Saharan Africa (developing only)?
Make the answer very short. 0.01. What is the ratio of the Aid flow from UN agencies (US$) in 2008 in Lower middle income to that in Sub-Saharan Africa (developing only)?
Offer a very short reply. 0.09. What is the ratio of the Aid flow from UN agencies (US$) in 2009 in Lower middle income to that in Sub-Saharan Africa (developing only)?
Offer a very short reply. 0.11. What is the ratio of the Aid flow from UN agencies (US$) in 2010 in Lower middle income to that in Sub-Saharan Africa (developing only)?
Provide a short and direct response. 0.12. What is the ratio of the Aid flow from UN agencies (US$) of 2007 in Lower middle income to that in Burundi?
Give a very brief answer. 0.02. What is the ratio of the Aid flow from UN agencies (US$) of 2008 in Lower middle income to that in Burundi?
Offer a terse response. 0.22. What is the ratio of the Aid flow from UN agencies (US$) in 2009 in Lower middle income to that in Burundi?
Your response must be concise. 0.48. What is the ratio of the Aid flow from UN agencies (US$) in 2010 in Lower middle income to that in Burundi?
Keep it short and to the point. 0.91. What is the ratio of the Aid flow from UN agencies (US$) in 2007 in Lower middle income to that in Cote d'Ivoire?
Your answer should be very brief. 1. What is the ratio of the Aid flow from UN agencies (US$) of 2008 in Lower middle income to that in Cote d'Ivoire?
Keep it short and to the point. 1. What is the ratio of the Aid flow from UN agencies (US$) in 2009 in Lower middle income to that in Cote d'Ivoire?
Ensure brevity in your answer.  1.05. What is the ratio of the Aid flow from UN agencies (US$) in 2010 in Lower middle income to that in Cote d'Ivoire?
Make the answer very short. 7.91. What is the ratio of the Aid flow from UN agencies (US$) in 2007 in Sub-Saharan Africa (all income levels) to that in Sub-Saharan Africa (developing only)?
Ensure brevity in your answer.  1. What is the ratio of the Aid flow from UN agencies (US$) in 2010 in Sub-Saharan Africa (all income levels) to that in Sub-Saharan Africa (developing only)?
Your answer should be very brief. 1. What is the ratio of the Aid flow from UN agencies (US$) in 2007 in Sub-Saharan Africa (all income levels) to that in Burundi?
Provide a succinct answer. 2.54. What is the ratio of the Aid flow from UN agencies (US$) in 2008 in Sub-Saharan Africa (all income levels) to that in Burundi?
Give a very brief answer. 2.44. What is the ratio of the Aid flow from UN agencies (US$) in 2009 in Sub-Saharan Africa (all income levels) to that in Burundi?
Provide a short and direct response. 4.3. What is the ratio of the Aid flow from UN agencies (US$) of 2010 in Sub-Saharan Africa (all income levels) to that in Burundi?
Your answer should be compact. 7.27. What is the ratio of the Aid flow from UN agencies (US$) in 2007 in Sub-Saharan Africa (all income levels) to that in Cote d'Ivoire?
Your answer should be compact. 159.17. What is the ratio of the Aid flow from UN agencies (US$) of 2008 in Sub-Saharan Africa (all income levels) to that in Cote d'Ivoire?
Give a very brief answer. 11.01. What is the ratio of the Aid flow from UN agencies (US$) in 2009 in Sub-Saharan Africa (all income levels) to that in Cote d'Ivoire?
Your answer should be very brief. 9.5. What is the ratio of the Aid flow from UN agencies (US$) of 2010 in Sub-Saharan Africa (all income levels) to that in Cote d'Ivoire?
Provide a short and direct response. 63.4. What is the ratio of the Aid flow from UN agencies (US$) of 2007 in Sub-Saharan Africa (developing only) to that in Burundi?
Keep it short and to the point. 2.54. What is the ratio of the Aid flow from UN agencies (US$) of 2008 in Sub-Saharan Africa (developing only) to that in Burundi?
Your answer should be compact. 2.44. What is the ratio of the Aid flow from UN agencies (US$) in 2009 in Sub-Saharan Africa (developing only) to that in Burundi?
Your answer should be very brief. 4.3. What is the ratio of the Aid flow from UN agencies (US$) of 2010 in Sub-Saharan Africa (developing only) to that in Burundi?
Make the answer very short. 7.27. What is the ratio of the Aid flow from UN agencies (US$) of 2007 in Sub-Saharan Africa (developing only) to that in Cote d'Ivoire?
Your answer should be very brief. 159.17. What is the ratio of the Aid flow from UN agencies (US$) in 2008 in Sub-Saharan Africa (developing only) to that in Cote d'Ivoire?
Your answer should be compact. 11.01. What is the ratio of the Aid flow from UN agencies (US$) in 2009 in Sub-Saharan Africa (developing only) to that in Cote d'Ivoire?
Make the answer very short. 9.5. What is the ratio of the Aid flow from UN agencies (US$) in 2010 in Sub-Saharan Africa (developing only) to that in Cote d'Ivoire?
Provide a succinct answer. 63.4. What is the ratio of the Aid flow from UN agencies (US$) in 2007 in Burundi to that in Cote d'Ivoire?
Your response must be concise. 62.67. What is the ratio of the Aid flow from UN agencies (US$) of 2008 in Burundi to that in Cote d'Ivoire?
Offer a terse response. 4.51. What is the ratio of the Aid flow from UN agencies (US$) of 2009 in Burundi to that in Cote d'Ivoire?
Ensure brevity in your answer.  2.21. What is the ratio of the Aid flow from UN agencies (US$) in 2010 in Burundi to that in Cote d'Ivoire?
Your response must be concise. 8.72. What is the difference between the highest and the second highest Aid flow from UN agencies (US$) in 2008?
Make the answer very short. 0. What is the difference between the highest and the second highest Aid flow from UN agencies (US$) in 2010?
Offer a terse response. 4.59e+06. What is the difference between the highest and the lowest Aid flow from UN agencies (US$) of 2007?
Provide a succinct answer. 9.49e+06. What is the difference between the highest and the lowest Aid flow from UN agencies (US$) in 2008?
Make the answer very short. 3.05e+07. What is the difference between the highest and the lowest Aid flow from UN agencies (US$) of 2009?
Provide a short and direct response. 3.64e+07. What is the difference between the highest and the lowest Aid flow from UN agencies (US$) of 2010?
Your answer should be compact. 4.52e+07. 